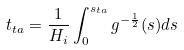Convert formula to latex. <formula><loc_0><loc_0><loc_500><loc_500>t _ { t a } = \frac { 1 } { H _ { i } } \int _ { 0 } ^ { s _ { t a } } g ^ { - \frac { 1 } { 2 } } ( s ) d s</formula> 